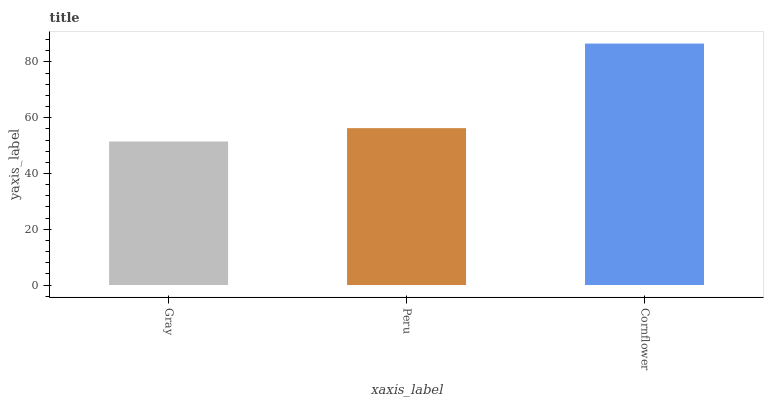Is Gray the minimum?
Answer yes or no. Yes. Is Cornflower the maximum?
Answer yes or no. Yes. Is Peru the minimum?
Answer yes or no. No. Is Peru the maximum?
Answer yes or no. No. Is Peru greater than Gray?
Answer yes or no. Yes. Is Gray less than Peru?
Answer yes or no. Yes. Is Gray greater than Peru?
Answer yes or no. No. Is Peru less than Gray?
Answer yes or no. No. Is Peru the high median?
Answer yes or no. Yes. Is Peru the low median?
Answer yes or no. Yes. Is Cornflower the high median?
Answer yes or no. No. Is Gray the low median?
Answer yes or no. No. 